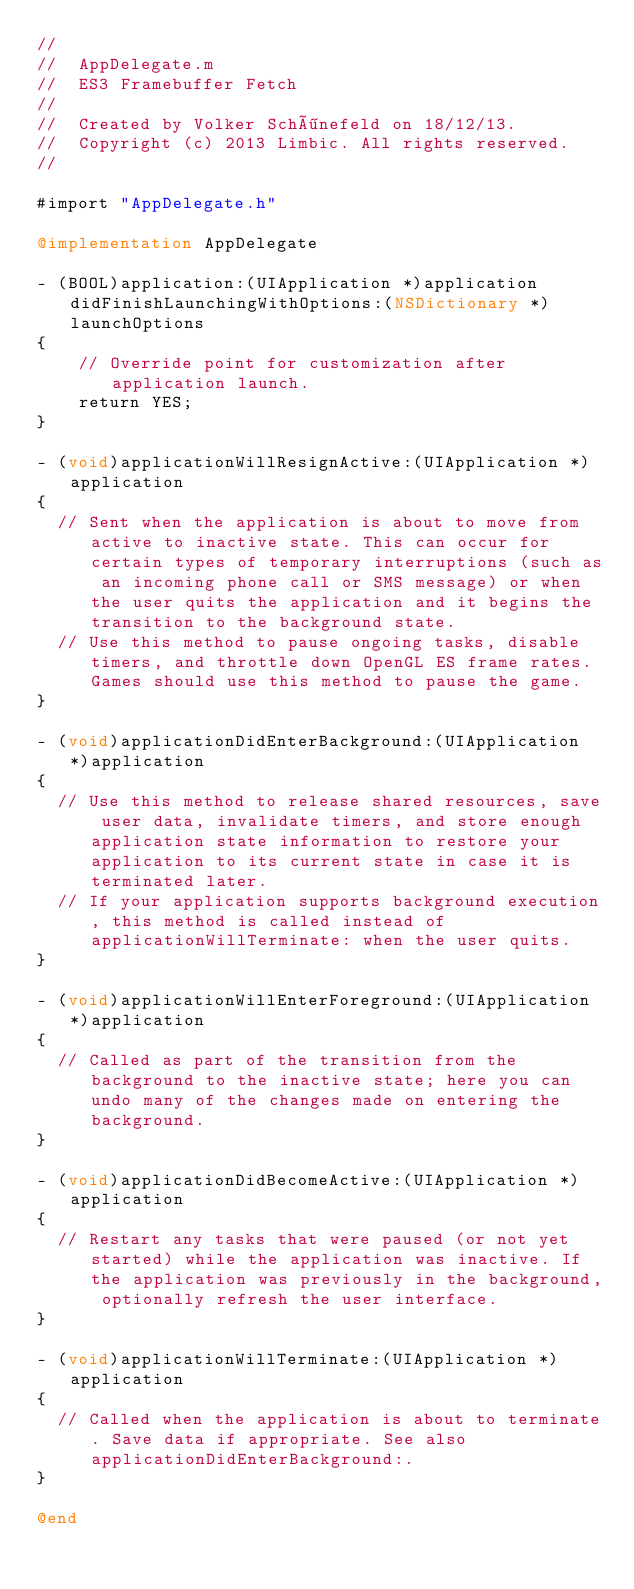<code> <loc_0><loc_0><loc_500><loc_500><_ObjectiveC_>//
//  AppDelegate.m
//  ES3 Framebuffer Fetch
//
//  Created by Volker Schönefeld on 18/12/13.
//  Copyright (c) 2013 Limbic. All rights reserved.
//

#import "AppDelegate.h"

@implementation AppDelegate

- (BOOL)application:(UIApplication *)application didFinishLaunchingWithOptions:(NSDictionary *)launchOptions
{
    // Override point for customization after application launch.
    return YES;
}
							
- (void)applicationWillResignActive:(UIApplication *)application
{
  // Sent when the application is about to move from active to inactive state. This can occur for certain types of temporary interruptions (such as an incoming phone call or SMS message) or when the user quits the application and it begins the transition to the background state.
  // Use this method to pause ongoing tasks, disable timers, and throttle down OpenGL ES frame rates. Games should use this method to pause the game.
}

- (void)applicationDidEnterBackground:(UIApplication *)application
{
  // Use this method to release shared resources, save user data, invalidate timers, and store enough application state information to restore your application to its current state in case it is terminated later. 
  // If your application supports background execution, this method is called instead of applicationWillTerminate: when the user quits.
}

- (void)applicationWillEnterForeground:(UIApplication *)application
{
  // Called as part of the transition from the background to the inactive state; here you can undo many of the changes made on entering the background.
}

- (void)applicationDidBecomeActive:(UIApplication *)application
{
  // Restart any tasks that were paused (or not yet started) while the application was inactive. If the application was previously in the background, optionally refresh the user interface.
}

- (void)applicationWillTerminate:(UIApplication *)application
{
  // Called when the application is about to terminate. Save data if appropriate. See also applicationDidEnterBackground:.
}

@end
</code> 